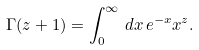Convert formula to latex. <formula><loc_0><loc_0><loc_500><loc_500>\Gamma ( z + 1 ) = \int _ { 0 } ^ { \infty } \, d x \, e ^ { - x } x ^ { z } .</formula> 